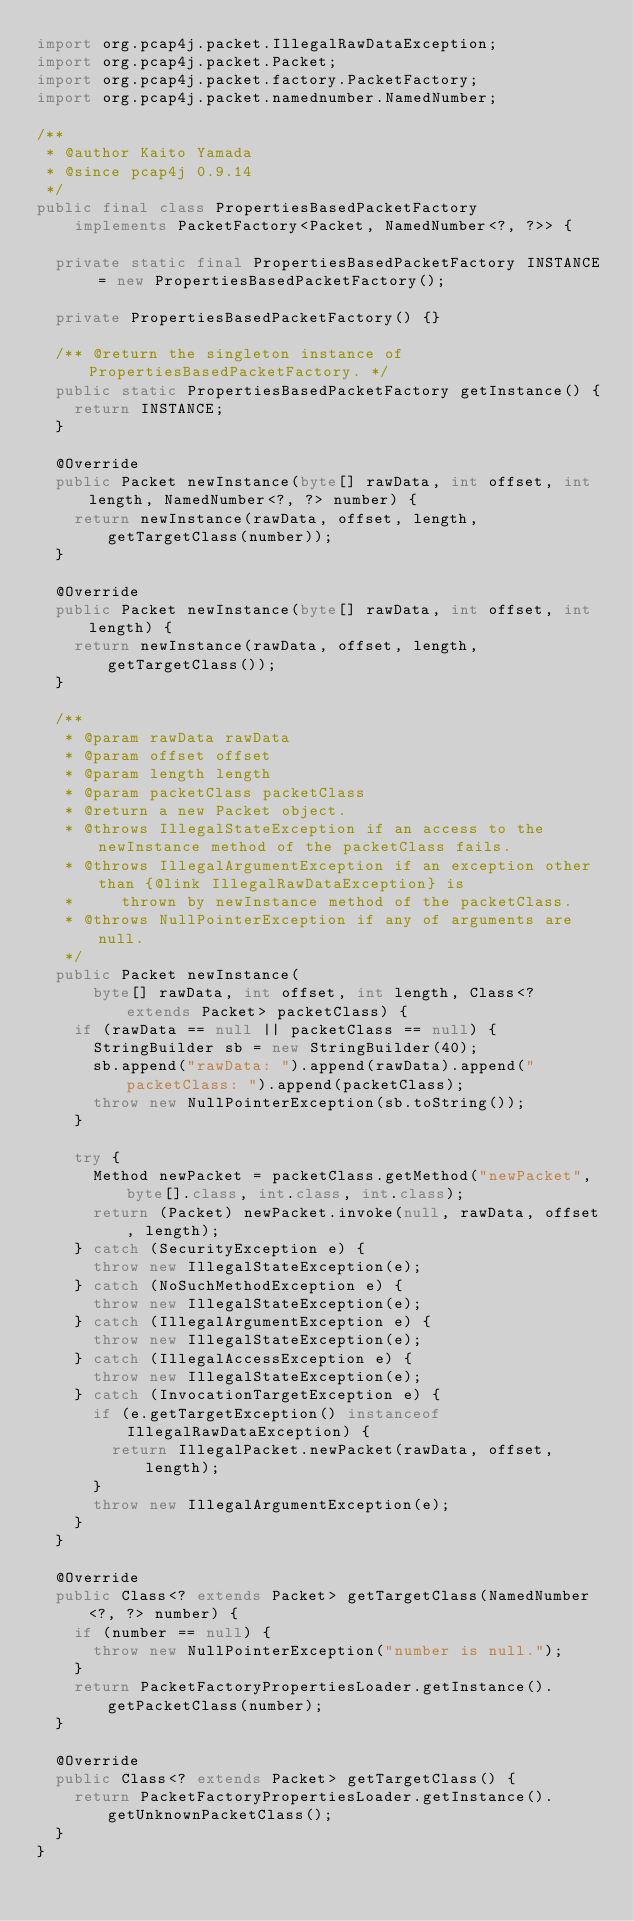<code> <loc_0><loc_0><loc_500><loc_500><_Java_>import org.pcap4j.packet.IllegalRawDataException;
import org.pcap4j.packet.Packet;
import org.pcap4j.packet.factory.PacketFactory;
import org.pcap4j.packet.namednumber.NamedNumber;

/**
 * @author Kaito Yamada
 * @since pcap4j 0.9.14
 */
public final class PropertiesBasedPacketFactory
    implements PacketFactory<Packet, NamedNumber<?, ?>> {

  private static final PropertiesBasedPacketFactory INSTANCE = new PropertiesBasedPacketFactory();

  private PropertiesBasedPacketFactory() {}

  /** @return the singleton instance of PropertiesBasedPacketFactory. */
  public static PropertiesBasedPacketFactory getInstance() {
    return INSTANCE;
  }

  @Override
  public Packet newInstance(byte[] rawData, int offset, int length, NamedNumber<?, ?> number) {
    return newInstance(rawData, offset, length, getTargetClass(number));
  }

  @Override
  public Packet newInstance(byte[] rawData, int offset, int length) {
    return newInstance(rawData, offset, length, getTargetClass());
  }

  /**
   * @param rawData rawData
   * @param offset offset
   * @param length length
   * @param packetClass packetClass
   * @return a new Packet object.
   * @throws IllegalStateException if an access to the newInstance method of the packetClass fails.
   * @throws IllegalArgumentException if an exception other than {@link IllegalRawDataException} is
   *     thrown by newInstance method of the packetClass.
   * @throws NullPointerException if any of arguments are null.
   */
  public Packet newInstance(
      byte[] rawData, int offset, int length, Class<? extends Packet> packetClass) {
    if (rawData == null || packetClass == null) {
      StringBuilder sb = new StringBuilder(40);
      sb.append("rawData: ").append(rawData).append(" packetClass: ").append(packetClass);
      throw new NullPointerException(sb.toString());
    }

    try {
      Method newPacket = packetClass.getMethod("newPacket", byte[].class, int.class, int.class);
      return (Packet) newPacket.invoke(null, rawData, offset, length);
    } catch (SecurityException e) {
      throw new IllegalStateException(e);
    } catch (NoSuchMethodException e) {
      throw new IllegalStateException(e);
    } catch (IllegalArgumentException e) {
      throw new IllegalStateException(e);
    } catch (IllegalAccessException e) {
      throw new IllegalStateException(e);
    } catch (InvocationTargetException e) {
      if (e.getTargetException() instanceof IllegalRawDataException) {
        return IllegalPacket.newPacket(rawData, offset, length);
      }
      throw new IllegalArgumentException(e);
    }
  }

  @Override
  public Class<? extends Packet> getTargetClass(NamedNumber<?, ?> number) {
    if (number == null) {
      throw new NullPointerException("number is null.");
    }
    return PacketFactoryPropertiesLoader.getInstance().getPacketClass(number);
  }

  @Override
  public Class<? extends Packet> getTargetClass() {
    return PacketFactoryPropertiesLoader.getInstance().getUnknownPacketClass();
  }
}
</code> 